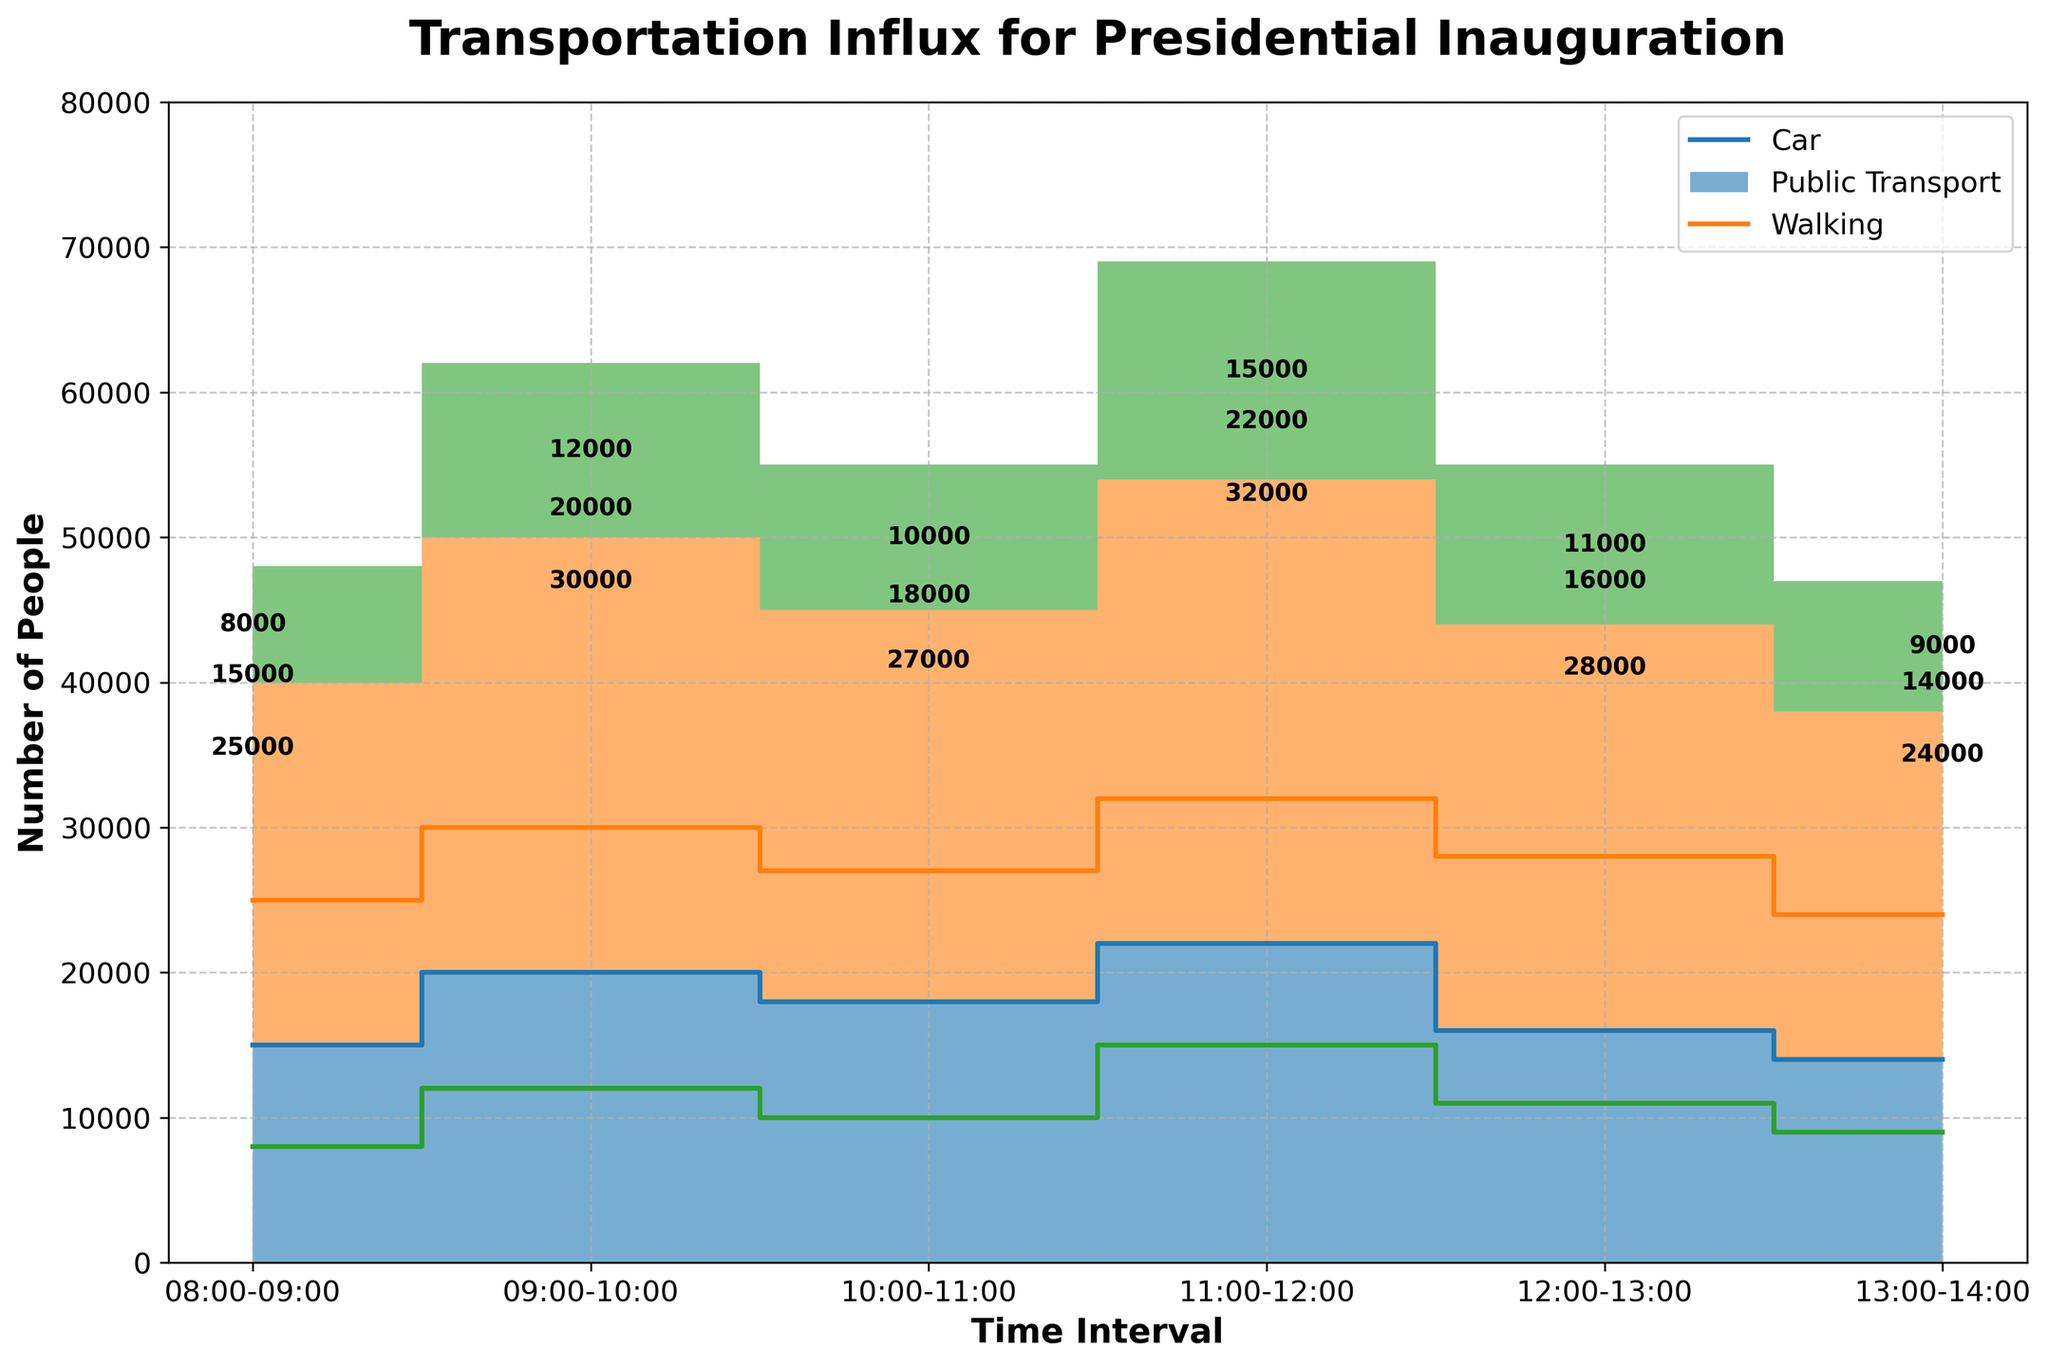What is the title of the chart? The title is located at the top of the chart. It provides a concise description of the chart's content. In this case, the title is "Transportation Influx for Presidential Inauguration."
Answer: Transportation Influx for Presidential Inauguration What is the transportation mode with the highest count between 11:00 and 12:00? Identify the mode corresponding to the highest step area within the time interval 11:00-12:00. Based on the data, Public Transport has the highest count of 32,000.
Answer: Public Transport What is the total count of people using public transport between 08:00 and 14:00? Sum the counts for Public Transport across all time intervals: 25,000 (08:00-09:00) + 30,000 (09:00-10:00) + 27,000 (10:00-11:00) + 32,000 (11:00-12:00) + 28,000 (12:00-13:00) + 24,000 (13:00-14:00) = 166,000.
Answer: 166,000 How does the number of people walking from 09:00-10:00 compare to the previous interval? Compare the values for Walking in the two intervals. From 08:00-09:00, there were 8,000 people walking. From 09:00-10:00, there were 12,000, an increase of 4,000.
Answer: An increase of 4,000 What is the total number of people arriving by car over the entire period shown in the chart? Sum the counts for Car across all time intervals: 15,000 (08:00-09:00) + 20,000 (09:00-10:00) + 18,000 (10:00-11:00) + 22,000 (11:00-12:00) + 16,000 (12:00-13:00) + 14,000 (13:00-14:00) = 105,000.
Answer: 105,000 Which time interval has the highest overall influx of people for the inauguration? Sum the counts for all modes within each time interval. The interval 11:00-12:00 has 22,000 (Car) + 32,000 (Public Transport) + 15,000 (Walking) = 69,000, which is the highest.
Answer: 11:00-12:00 During which time interval did the number of people arriving by car decrease compared to the previous interval? Compare consecutive intervals to find the decrease. The number of people arriving by car decreased from 22,000 (11:00-12:00) to 16,000 (12:00-13:00).
Answer: 12:00-13:00 Between 08:00 and 11:00, how many more people used public transport compared to walking? Sum the counts for Public Transport and Walking from 08:00-11:00: Public Transport: 25,000 + 30,000 + 27,000 = 82,000; Walking: 8,000 + 12,000 + 10,000 = 30,000; The difference is 82,000 - 30,000 = 52,000.
Answer: 52,000 